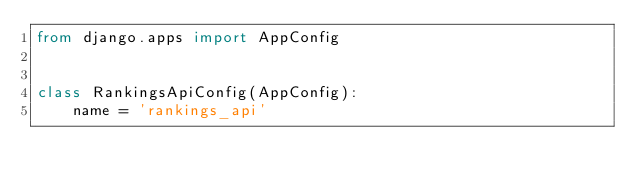Convert code to text. <code><loc_0><loc_0><loc_500><loc_500><_Python_>from django.apps import AppConfig


class RankingsApiConfig(AppConfig):
    name = 'rankings_api'
</code> 